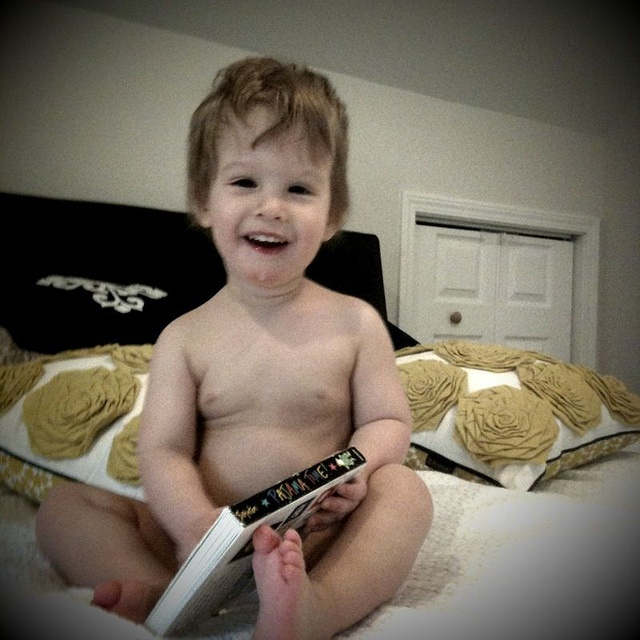Describe the objects in this image and their specific colors. I can see bed in black, gray, darkgray, and tan tones, people in black, tan, and gray tones, and book in black, darkgray, gray, and lightgray tones in this image. 